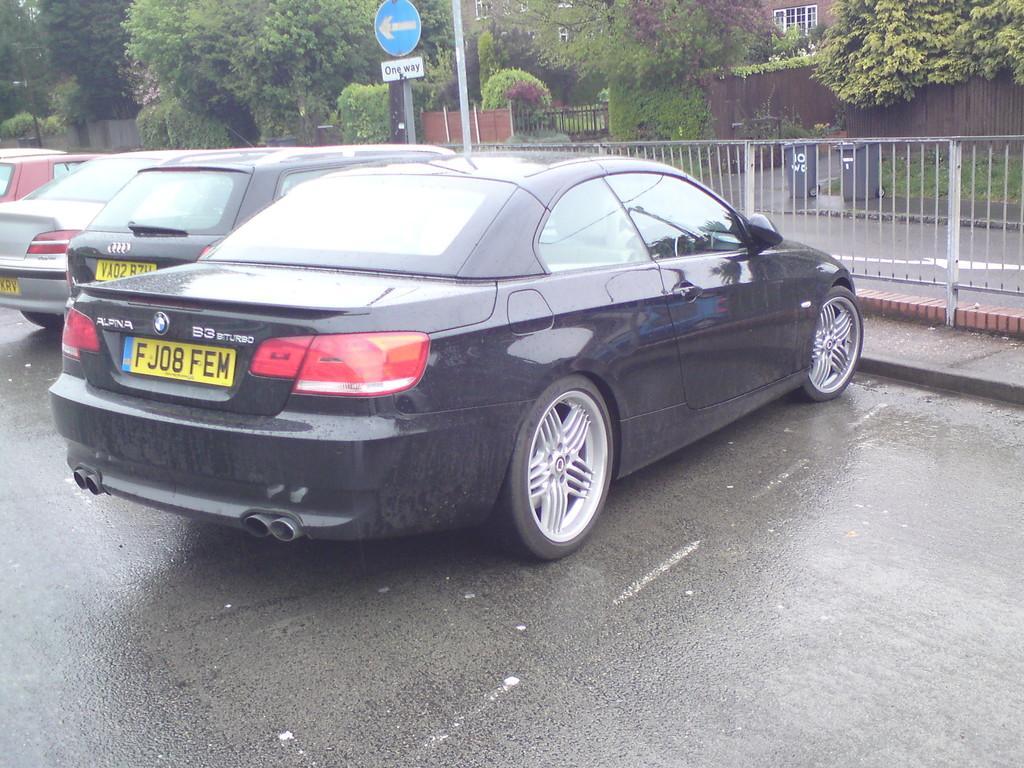In one or two sentences, can you explain what this image depicts? In this image we can see a few cars parked on the road, a fence, a building and some trees in front of the building and two trash bins. 